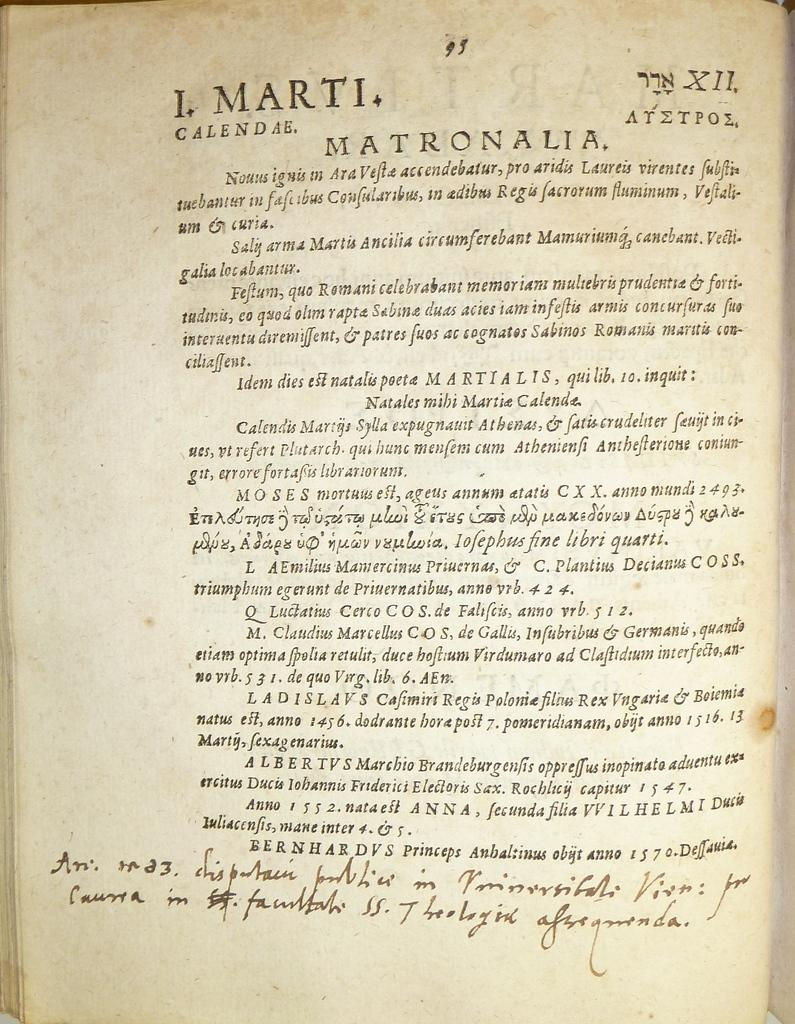Provide a one-sentence caption for the provided image. A page of text written in a foreign language is about Matronalia, and has some handwriting at the bottom. 